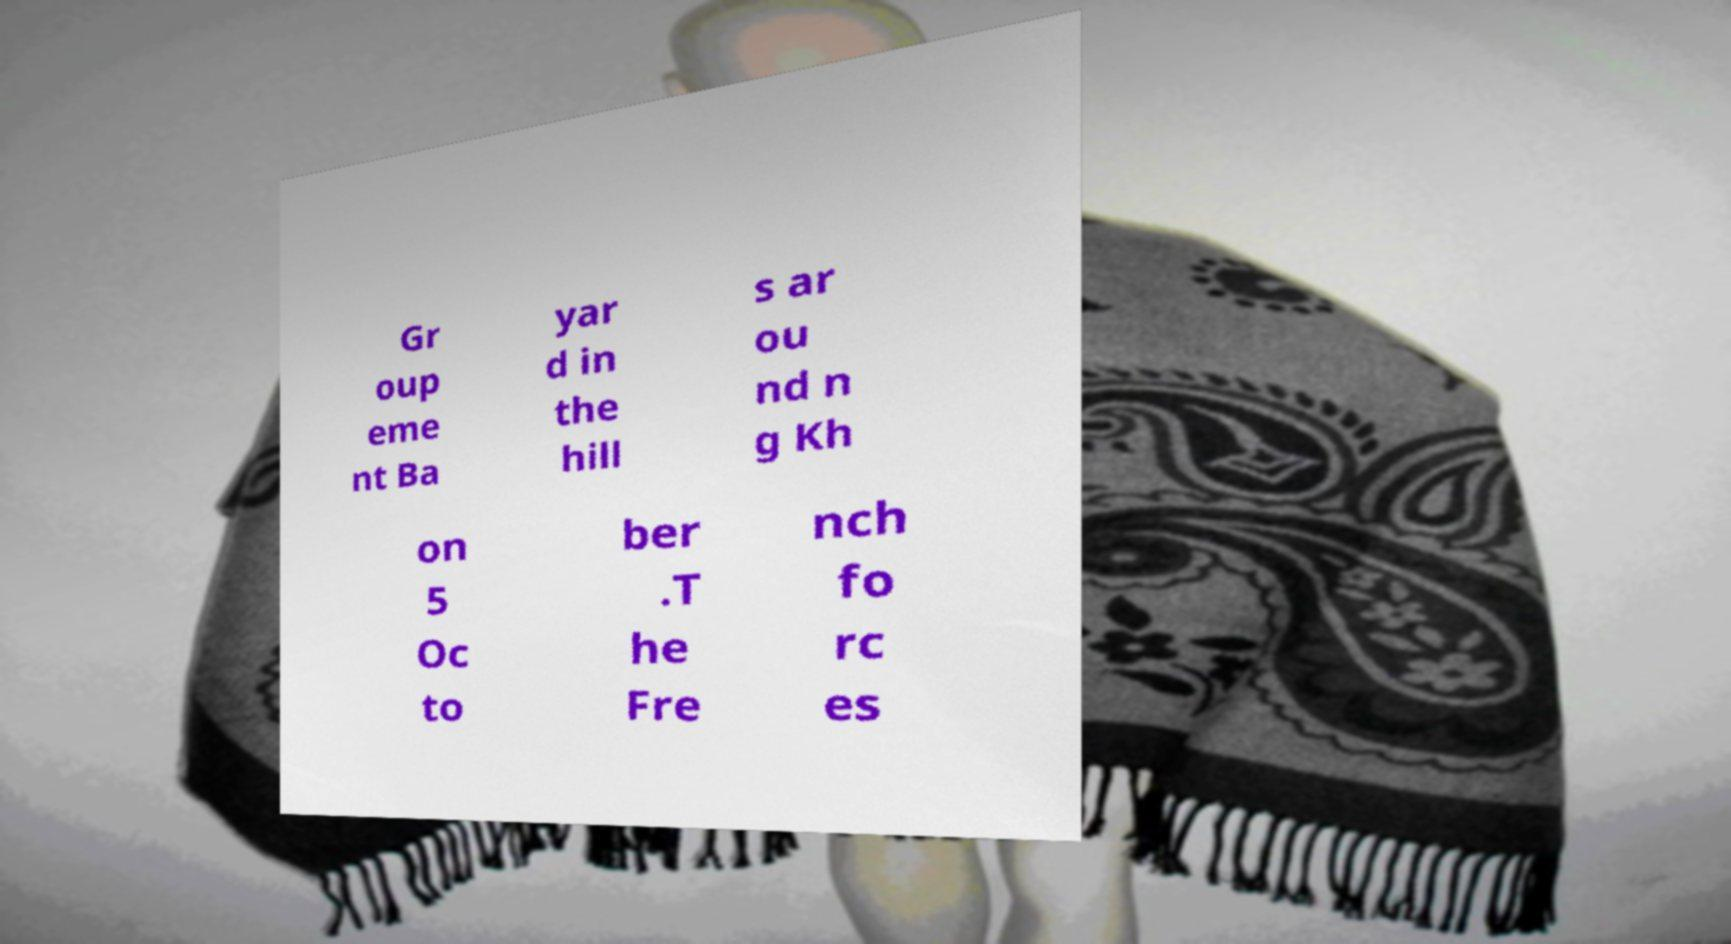Can you accurately transcribe the text from the provided image for me? Gr oup eme nt Ba yar d in the hill s ar ou nd n g Kh on 5 Oc to ber .T he Fre nch fo rc es 